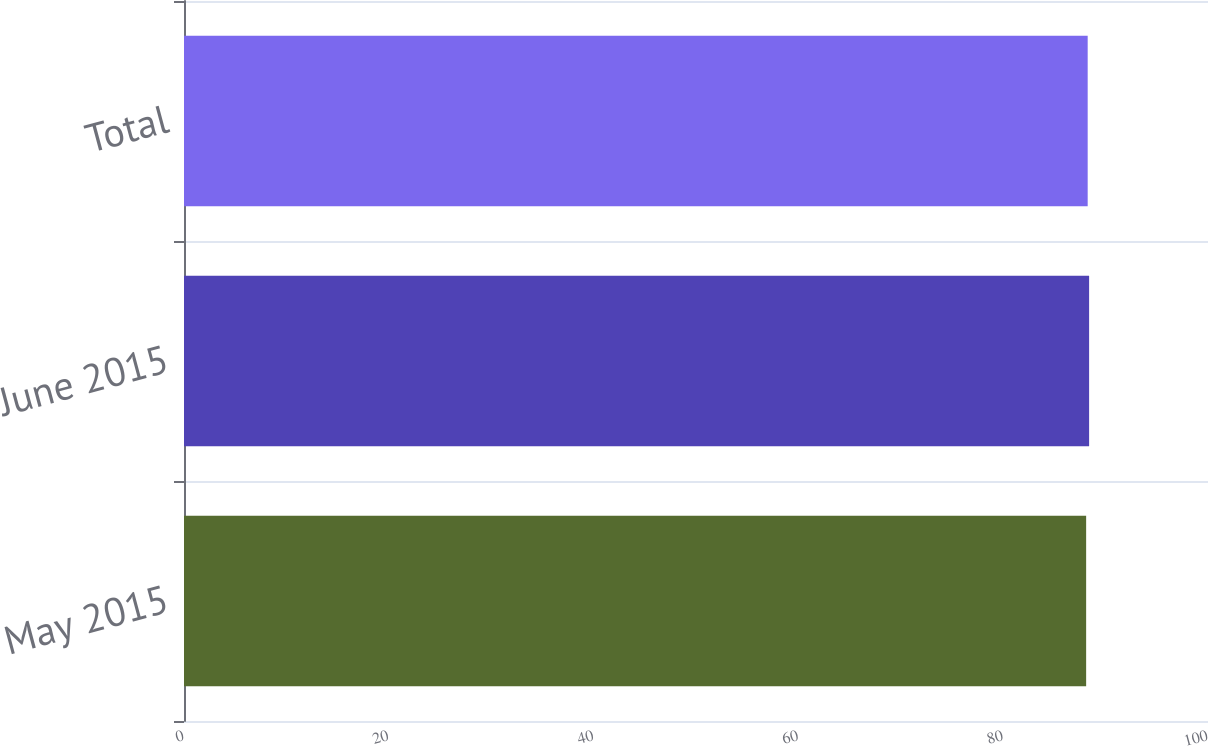Convert chart. <chart><loc_0><loc_0><loc_500><loc_500><bar_chart><fcel>May 2015<fcel>June 2015<fcel>Total<nl><fcel>88.1<fcel>88.39<fcel>88.25<nl></chart> 